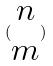Convert formula to latex. <formula><loc_0><loc_0><loc_500><loc_500>( \begin{matrix} n \\ m \end{matrix} )</formula> 